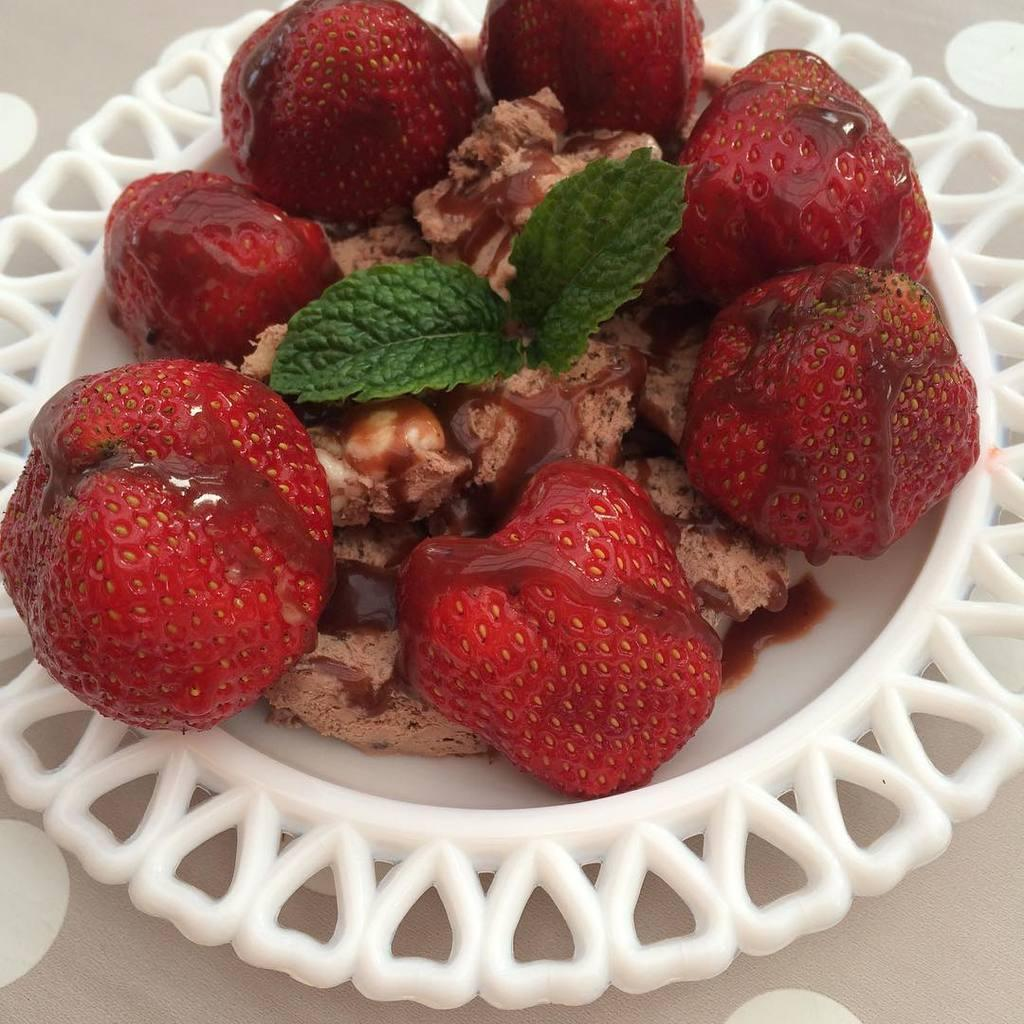What is present in the image? There is food in the image. What is the color of the plate on which the food is placed? The food is on a white color plate. What colors can be seen in the food? The food has red, green, and brown colors. What type of hair can be seen on the plate in the image? There is no hair present on the plate in the image. Is there a railway visible in the image? No, there is no railway present in the image. 